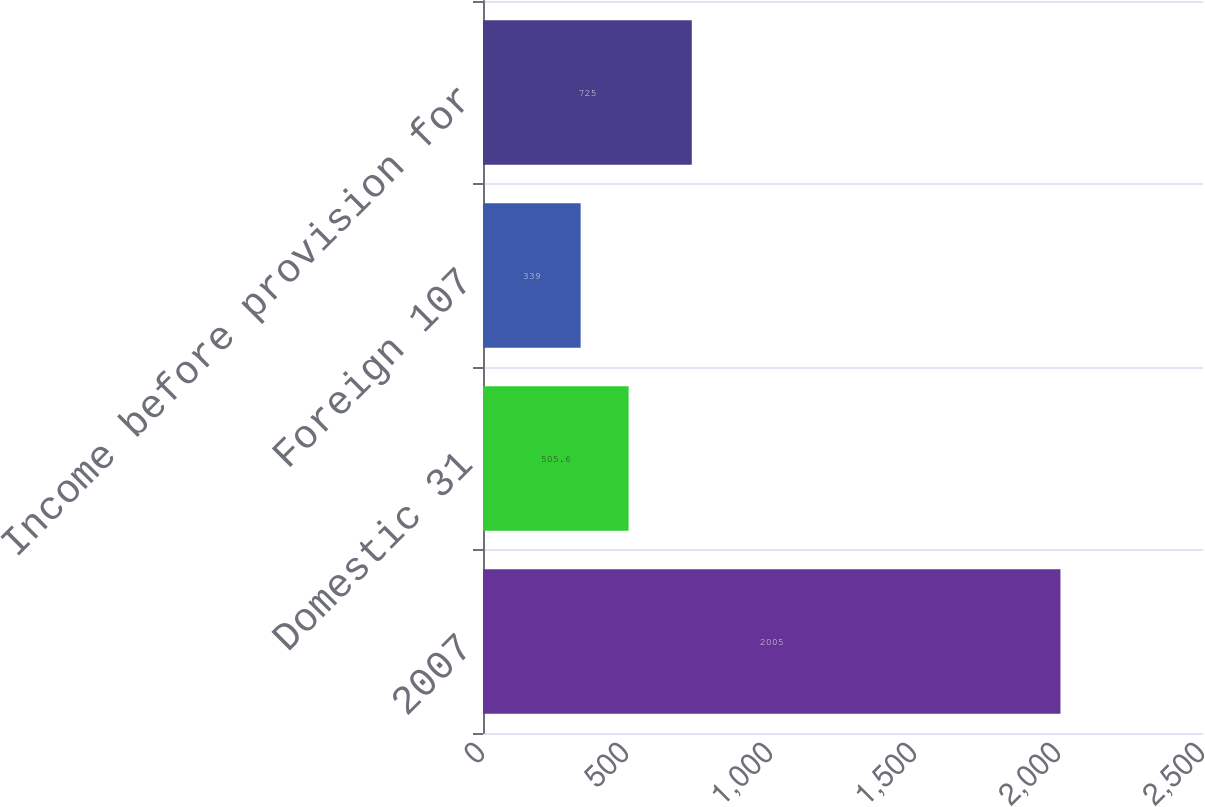Convert chart to OTSL. <chart><loc_0><loc_0><loc_500><loc_500><bar_chart><fcel>2007<fcel>Domestic 31<fcel>Foreign 107<fcel>Income before provision for<nl><fcel>2005<fcel>505.6<fcel>339<fcel>725<nl></chart> 